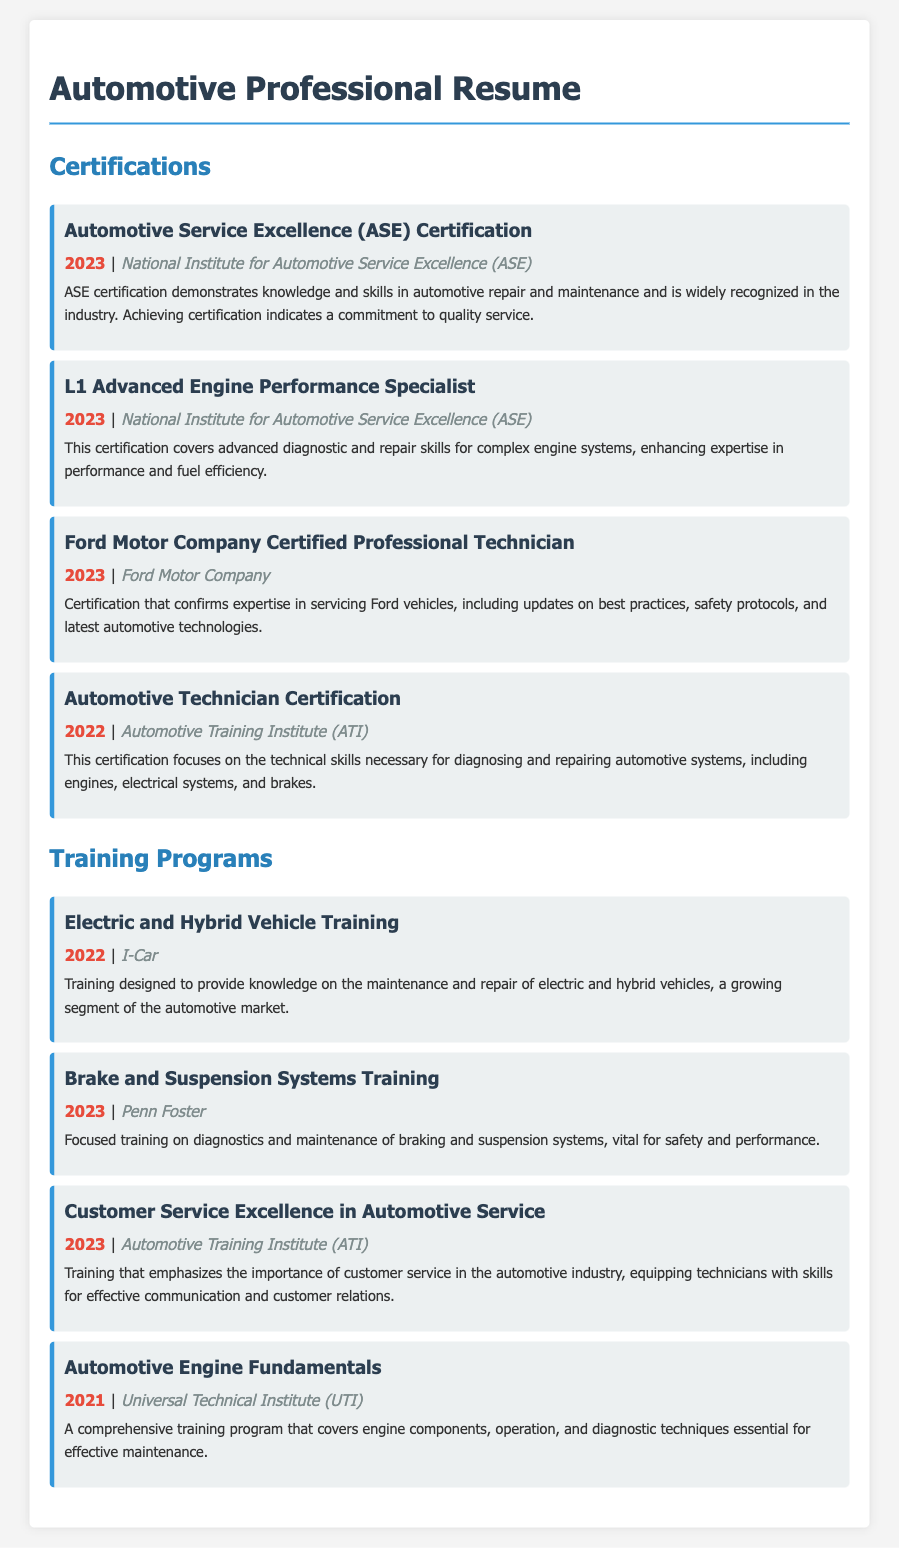What is the most recent certification obtained? The most recent certification listed is the Automotive Service Excellence (ASE) Certification, obtained in 2023.
Answer: 2023 Who is the organization behind the L1 Advanced Engine Performance Specialist certification? The L1 Advanced Engine Performance Specialist certification is provided by the National Institute for Automotive Service Excellence (ASE).
Answer: National Institute for Automotive Service Excellence (ASE) What type of vehicles does the Ford Motor Company Certified Professional Technician certification focus on? This certification focuses on servicing Ford vehicles.
Answer: Ford vehicles How many training programs are listed in the document? There are four training programs listed in total.
Answer: Four What is the main focus of the Electric and Hybrid Vehicle Training? The training provides knowledge on the maintenance and repair of electric and hybrid vehicles.
Answer: Maintenance and repair of electric and hybrid vehicles Which year's training program covers Brake and Suspension Systems? The Brake and Suspension Systems Training is from the year 2023.
Answer: 2023 What does the Customer Service Excellence in Automotive Service training emphasize? It emphasizes the importance of customer service in the automotive industry.
Answer: Importance of customer service Which organization offers the Automotive Engine Fundamentals training? The training is offered by the Universal Technical Institute (UTI).
Answer: Universal Technical Institute (UTI) What certification indicates a commitment to quality service? The Automotive Service Excellence (ASE) Certification indicates a commitment to quality service.
Answer: Automotive Service Excellence (ASE) Certification 